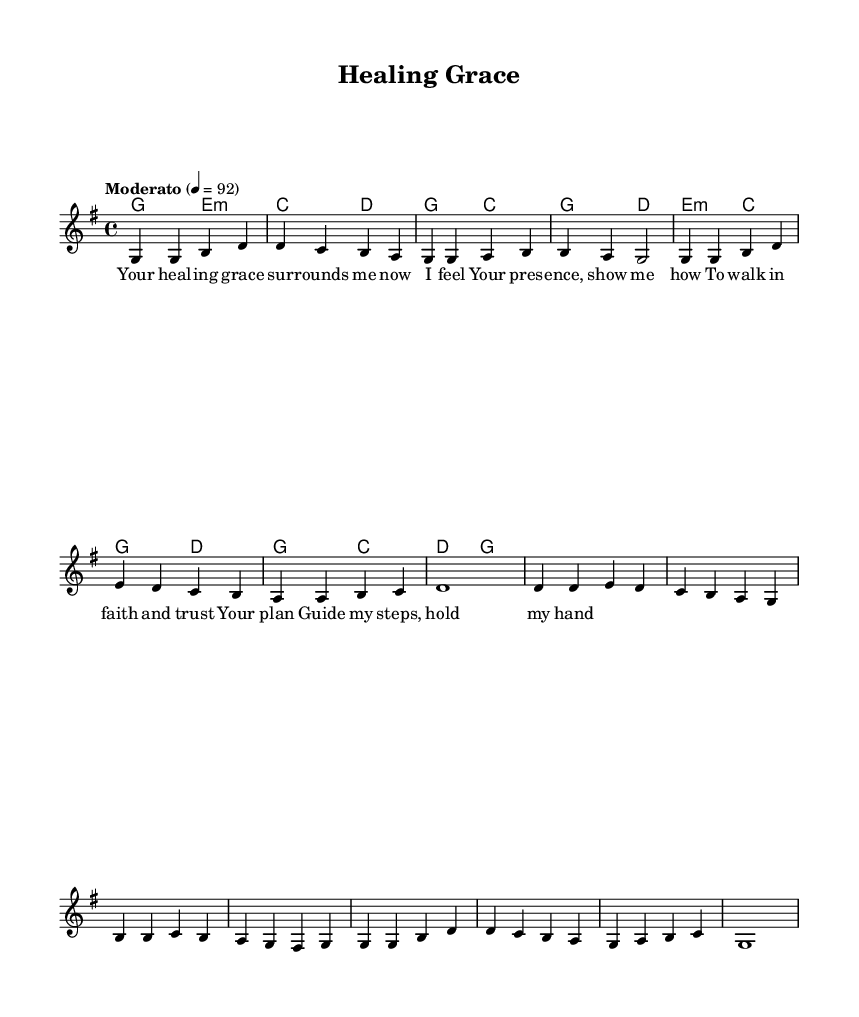What is the key signature of this music? The key signature is G major, which has one sharp (F#).
Answer: G major What is the time signature of this music? The time signature is 4/4, which indicates four beats per measure.
Answer: 4/4 What is the tempo marking of this piece? The tempo marking indicates a moderate tempo of 92 beats per minute.
Answer: Moderato 4 = 92 How many measures are in the melody section? By counting the measures in the melody part, there are a total of 8 measures in the excerpt.
Answer: 8 What is the theme of the lyrics in this piece? The lyrics focus on healing, divine presence, and guidance in faith.
Answer: Healing grace In which measure does the lyric "hold my hand" appear? The lyric "hold my hand" is found in the last measure of the verse.
Answer: Measure 4 What type of harmony is used in the chord progression? The harmony primarily consists of major and minor chords, which creates a warm and uplifting atmosphere typical of contemporary Christian music.
Answer: Major and minor chords 